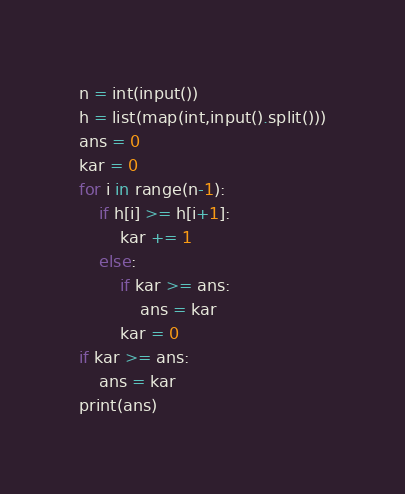Convert code to text. <code><loc_0><loc_0><loc_500><loc_500><_Python_>n = int(input())
h = list(map(int,input().split()))
ans = 0
kar = 0
for i in range(n-1):
    if h[i] >= h[i+1]:
        kar += 1
    else:
        if kar >= ans:
            ans = kar
        kar = 0
if kar >= ans:
    ans = kar
print(ans)</code> 